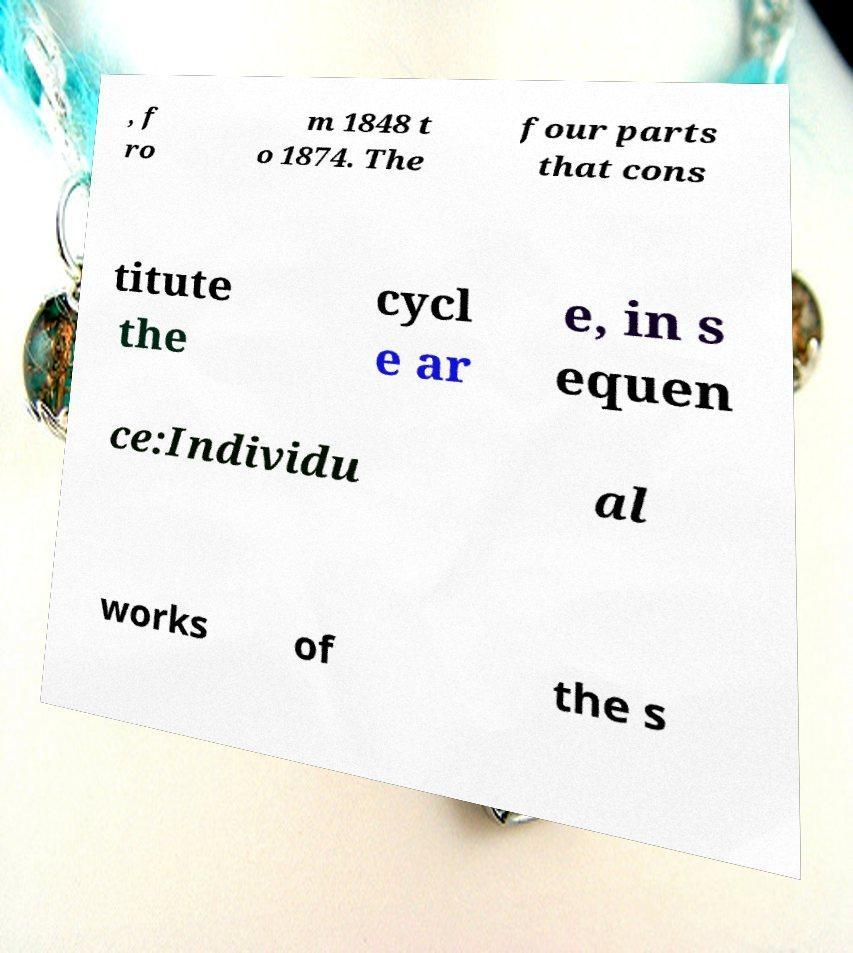Could you assist in decoding the text presented in this image and type it out clearly? , f ro m 1848 t o 1874. The four parts that cons titute the cycl e ar e, in s equen ce:Individu al works of the s 